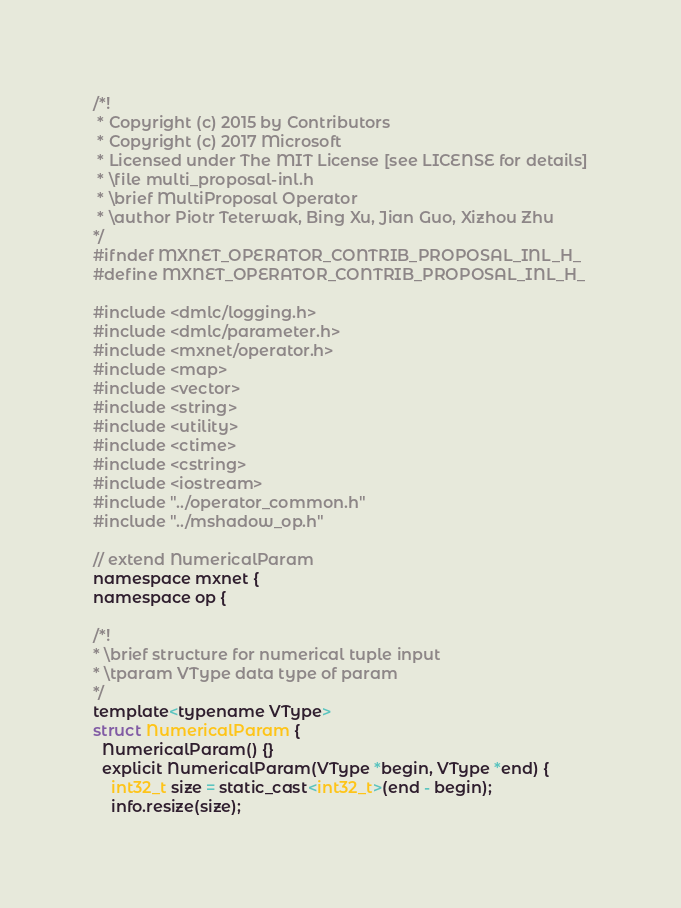<code> <loc_0><loc_0><loc_500><loc_500><_C_>/*!
 * Copyright (c) 2015 by Contributors
 * Copyright (c) 2017 Microsoft
 * Licensed under The MIT License [see LICENSE for details]
 * \file multi_proposal-inl.h
 * \brief MultiProposal Operator
 * \author Piotr Teterwak, Bing Xu, Jian Guo, Xizhou Zhu
*/
#ifndef MXNET_OPERATOR_CONTRIB_PROPOSAL_INL_H_
#define MXNET_OPERATOR_CONTRIB_PROPOSAL_INL_H_

#include <dmlc/logging.h>
#include <dmlc/parameter.h>
#include <mxnet/operator.h>
#include <map>
#include <vector>
#include <string>
#include <utility>
#include <ctime>
#include <cstring>
#include <iostream>
#include "../operator_common.h"
#include "../mshadow_op.h"

// extend NumericalParam
namespace mxnet {
namespace op {

/*!
* \brief structure for numerical tuple input
* \tparam VType data type of param
*/
template<typename VType>
struct NumericalParam {
  NumericalParam() {}
  explicit NumericalParam(VType *begin, VType *end) {
    int32_t size = static_cast<int32_t>(end - begin);
    info.resize(size);</code> 